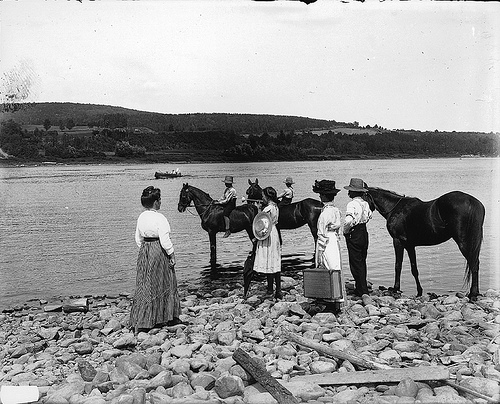Can you describe the clothing worn by the people in this image? The individuals in the photograph are dressed in attire typical of the late 19th or early 20th century. The women wear long skirts and full-sleeved blouses, which were common for everyday wear in rural areas during this period. The men are dressed in light shirts and suspenders, with wide-brimmed hats that suggest outdoor work or travel. 